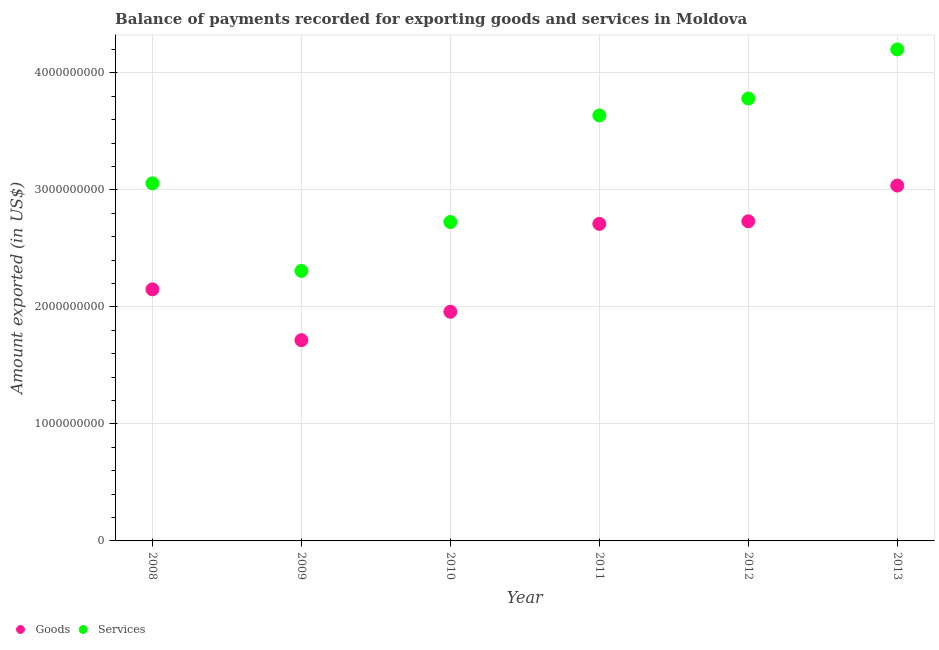Is the number of dotlines equal to the number of legend labels?
Provide a short and direct response. Yes. What is the amount of goods exported in 2013?
Make the answer very short. 3.04e+09. Across all years, what is the maximum amount of goods exported?
Your response must be concise. 3.04e+09. Across all years, what is the minimum amount of goods exported?
Offer a terse response. 1.72e+09. In which year was the amount of goods exported minimum?
Give a very brief answer. 2009. What is the total amount of goods exported in the graph?
Provide a succinct answer. 1.43e+1. What is the difference between the amount of services exported in 2010 and that in 2012?
Make the answer very short. -1.06e+09. What is the difference between the amount of goods exported in 2011 and the amount of services exported in 2012?
Your answer should be compact. -1.07e+09. What is the average amount of goods exported per year?
Ensure brevity in your answer.  2.38e+09. In the year 2012, what is the difference between the amount of services exported and amount of goods exported?
Your response must be concise. 1.05e+09. What is the ratio of the amount of goods exported in 2009 to that in 2012?
Provide a succinct answer. 0.63. What is the difference between the highest and the second highest amount of services exported?
Make the answer very short. 4.20e+08. What is the difference between the highest and the lowest amount of services exported?
Your response must be concise. 1.89e+09. In how many years, is the amount of services exported greater than the average amount of services exported taken over all years?
Keep it short and to the point. 3. Is the sum of the amount of goods exported in 2008 and 2009 greater than the maximum amount of services exported across all years?
Provide a short and direct response. No. Does the amount of goods exported monotonically increase over the years?
Offer a terse response. No. Is the amount of goods exported strictly less than the amount of services exported over the years?
Offer a very short reply. Yes. How many dotlines are there?
Offer a very short reply. 2. Are the values on the major ticks of Y-axis written in scientific E-notation?
Offer a very short reply. No. Does the graph contain any zero values?
Ensure brevity in your answer.  No. Where does the legend appear in the graph?
Keep it short and to the point. Bottom left. How many legend labels are there?
Keep it short and to the point. 2. What is the title of the graph?
Provide a short and direct response. Balance of payments recorded for exporting goods and services in Moldova. Does "Health Care" appear as one of the legend labels in the graph?
Provide a short and direct response. No. What is the label or title of the X-axis?
Keep it short and to the point. Year. What is the label or title of the Y-axis?
Provide a succinct answer. Amount exported (in US$). What is the Amount exported (in US$) of Goods in 2008?
Offer a very short reply. 2.15e+09. What is the Amount exported (in US$) in Services in 2008?
Your answer should be very brief. 3.06e+09. What is the Amount exported (in US$) in Goods in 2009?
Offer a very short reply. 1.72e+09. What is the Amount exported (in US$) of Services in 2009?
Provide a succinct answer. 2.31e+09. What is the Amount exported (in US$) of Goods in 2010?
Provide a succinct answer. 1.96e+09. What is the Amount exported (in US$) of Services in 2010?
Ensure brevity in your answer.  2.73e+09. What is the Amount exported (in US$) in Goods in 2011?
Provide a succinct answer. 2.71e+09. What is the Amount exported (in US$) in Services in 2011?
Your response must be concise. 3.64e+09. What is the Amount exported (in US$) in Goods in 2012?
Make the answer very short. 2.73e+09. What is the Amount exported (in US$) in Services in 2012?
Provide a succinct answer. 3.78e+09. What is the Amount exported (in US$) in Goods in 2013?
Provide a short and direct response. 3.04e+09. What is the Amount exported (in US$) in Services in 2013?
Keep it short and to the point. 4.20e+09. Across all years, what is the maximum Amount exported (in US$) in Goods?
Make the answer very short. 3.04e+09. Across all years, what is the maximum Amount exported (in US$) of Services?
Your answer should be very brief. 4.20e+09. Across all years, what is the minimum Amount exported (in US$) in Goods?
Ensure brevity in your answer.  1.72e+09. Across all years, what is the minimum Amount exported (in US$) in Services?
Give a very brief answer. 2.31e+09. What is the total Amount exported (in US$) in Goods in the graph?
Ensure brevity in your answer.  1.43e+1. What is the total Amount exported (in US$) in Services in the graph?
Provide a short and direct response. 1.97e+1. What is the difference between the Amount exported (in US$) in Goods in 2008 and that in 2009?
Ensure brevity in your answer.  4.34e+08. What is the difference between the Amount exported (in US$) of Services in 2008 and that in 2009?
Offer a very short reply. 7.48e+08. What is the difference between the Amount exported (in US$) of Goods in 2008 and that in 2010?
Offer a very short reply. 1.92e+08. What is the difference between the Amount exported (in US$) of Services in 2008 and that in 2010?
Make the answer very short. 3.31e+08. What is the difference between the Amount exported (in US$) of Goods in 2008 and that in 2011?
Ensure brevity in your answer.  -5.60e+08. What is the difference between the Amount exported (in US$) of Services in 2008 and that in 2011?
Make the answer very short. -5.80e+08. What is the difference between the Amount exported (in US$) of Goods in 2008 and that in 2012?
Your answer should be very brief. -5.82e+08. What is the difference between the Amount exported (in US$) of Services in 2008 and that in 2012?
Your answer should be very brief. -7.25e+08. What is the difference between the Amount exported (in US$) in Goods in 2008 and that in 2013?
Give a very brief answer. -8.87e+08. What is the difference between the Amount exported (in US$) in Services in 2008 and that in 2013?
Ensure brevity in your answer.  -1.14e+09. What is the difference between the Amount exported (in US$) of Goods in 2009 and that in 2010?
Offer a terse response. -2.43e+08. What is the difference between the Amount exported (in US$) of Services in 2009 and that in 2010?
Ensure brevity in your answer.  -4.18e+08. What is the difference between the Amount exported (in US$) in Goods in 2009 and that in 2011?
Provide a succinct answer. -9.94e+08. What is the difference between the Amount exported (in US$) in Services in 2009 and that in 2011?
Provide a short and direct response. -1.33e+09. What is the difference between the Amount exported (in US$) in Goods in 2009 and that in 2012?
Your response must be concise. -1.02e+09. What is the difference between the Amount exported (in US$) in Services in 2009 and that in 2012?
Your answer should be very brief. -1.47e+09. What is the difference between the Amount exported (in US$) in Goods in 2009 and that in 2013?
Your answer should be very brief. -1.32e+09. What is the difference between the Amount exported (in US$) in Services in 2009 and that in 2013?
Offer a very short reply. -1.89e+09. What is the difference between the Amount exported (in US$) of Goods in 2010 and that in 2011?
Make the answer very short. -7.51e+08. What is the difference between the Amount exported (in US$) of Services in 2010 and that in 2011?
Provide a short and direct response. -9.11e+08. What is the difference between the Amount exported (in US$) of Goods in 2010 and that in 2012?
Provide a short and direct response. -7.73e+08. What is the difference between the Amount exported (in US$) in Services in 2010 and that in 2012?
Keep it short and to the point. -1.06e+09. What is the difference between the Amount exported (in US$) in Goods in 2010 and that in 2013?
Offer a terse response. -1.08e+09. What is the difference between the Amount exported (in US$) in Services in 2010 and that in 2013?
Keep it short and to the point. -1.48e+09. What is the difference between the Amount exported (in US$) in Goods in 2011 and that in 2012?
Ensure brevity in your answer.  -2.19e+07. What is the difference between the Amount exported (in US$) of Services in 2011 and that in 2012?
Your answer should be very brief. -1.45e+08. What is the difference between the Amount exported (in US$) in Goods in 2011 and that in 2013?
Your answer should be very brief. -3.28e+08. What is the difference between the Amount exported (in US$) in Services in 2011 and that in 2013?
Make the answer very short. -5.64e+08. What is the difference between the Amount exported (in US$) of Goods in 2012 and that in 2013?
Your answer should be very brief. -3.06e+08. What is the difference between the Amount exported (in US$) in Services in 2012 and that in 2013?
Provide a succinct answer. -4.20e+08. What is the difference between the Amount exported (in US$) of Goods in 2008 and the Amount exported (in US$) of Services in 2009?
Ensure brevity in your answer.  -1.58e+08. What is the difference between the Amount exported (in US$) in Goods in 2008 and the Amount exported (in US$) in Services in 2010?
Your response must be concise. -5.75e+08. What is the difference between the Amount exported (in US$) in Goods in 2008 and the Amount exported (in US$) in Services in 2011?
Your answer should be compact. -1.49e+09. What is the difference between the Amount exported (in US$) in Goods in 2008 and the Amount exported (in US$) in Services in 2012?
Your answer should be very brief. -1.63e+09. What is the difference between the Amount exported (in US$) of Goods in 2008 and the Amount exported (in US$) of Services in 2013?
Your answer should be very brief. -2.05e+09. What is the difference between the Amount exported (in US$) in Goods in 2009 and the Amount exported (in US$) in Services in 2010?
Offer a terse response. -1.01e+09. What is the difference between the Amount exported (in US$) of Goods in 2009 and the Amount exported (in US$) of Services in 2011?
Ensure brevity in your answer.  -1.92e+09. What is the difference between the Amount exported (in US$) in Goods in 2009 and the Amount exported (in US$) in Services in 2012?
Your response must be concise. -2.07e+09. What is the difference between the Amount exported (in US$) of Goods in 2009 and the Amount exported (in US$) of Services in 2013?
Your answer should be compact. -2.48e+09. What is the difference between the Amount exported (in US$) in Goods in 2010 and the Amount exported (in US$) in Services in 2011?
Give a very brief answer. -1.68e+09. What is the difference between the Amount exported (in US$) in Goods in 2010 and the Amount exported (in US$) in Services in 2012?
Ensure brevity in your answer.  -1.82e+09. What is the difference between the Amount exported (in US$) in Goods in 2010 and the Amount exported (in US$) in Services in 2013?
Provide a succinct answer. -2.24e+09. What is the difference between the Amount exported (in US$) in Goods in 2011 and the Amount exported (in US$) in Services in 2012?
Your response must be concise. -1.07e+09. What is the difference between the Amount exported (in US$) in Goods in 2011 and the Amount exported (in US$) in Services in 2013?
Your answer should be very brief. -1.49e+09. What is the difference between the Amount exported (in US$) in Goods in 2012 and the Amount exported (in US$) in Services in 2013?
Provide a short and direct response. -1.47e+09. What is the average Amount exported (in US$) of Goods per year?
Offer a very short reply. 2.38e+09. What is the average Amount exported (in US$) of Services per year?
Your response must be concise. 3.28e+09. In the year 2008, what is the difference between the Amount exported (in US$) in Goods and Amount exported (in US$) in Services?
Give a very brief answer. -9.06e+08. In the year 2009, what is the difference between the Amount exported (in US$) in Goods and Amount exported (in US$) in Services?
Provide a succinct answer. -5.92e+08. In the year 2010, what is the difference between the Amount exported (in US$) of Goods and Amount exported (in US$) of Services?
Make the answer very short. -7.67e+08. In the year 2011, what is the difference between the Amount exported (in US$) of Goods and Amount exported (in US$) of Services?
Give a very brief answer. -9.27e+08. In the year 2012, what is the difference between the Amount exported (in US$) of Goods and Amount exported (in US$) of Services?
Your answer should be very brief. -1.05e+09. In the year 2013, what is the difference between the Amount exported (in US$) of Goods and Amount exported (in US$) of Services?
Your response must be concise. -1.16e+09. What is the ratio of the Amount exported (in US$) of Goods in 2008 to that in 2009?
Offer a terse response. 1.25. What is the ratio of the Amount exported (in US$) of Services in 2008 to that in 2009?
Your answer should be very brief. 1.32. What is the ratio of the Amount exported (in US$) in Goods in 2008 to that in 2010?
Make the answer very short. 1.1. What is the ratio of the Amount exported (in US$) in Services in 2008 to that in 2010?
Provide a succinct answer. 1.12. What is the ratio of the Amount exported (in US$) of Goods in 2008 to that in 2011?
Provide a short and direct response. 0.79. What is the ratio of the Amount exported (in US$) in Services in 2008 to that in 2011?
Offer a very short reply. 0.84. What is the ratio of the Amount exported (in US$) of Goods in 2008 to that in 2012?
Keep it short and to the point. 0.79. What is the ratio of the Amount exported (in US$) of Services in 2008 to that in 2012?
Your answer should be compact. 0.81. What is the ratio of the Amount exported (in US$) in Goods in 2008 to that in 2013?
Your answer should be very brief. 0.71. What is the ratio of the Amount exported (in US$) in Services in 2008 to that in 2013?
Ensure brevity in your answer.  0.73. What is the ratio of the Amount exported (in US$) in Goods in 2009 to that in 2010?
Give a very brief answer. 0.88. What is the ratio of the Amount exported (in US$) of Services in 2009 to that in 2010?
Give a very brief answer. 0.85. What is the ratio of the Amount exported (in US$) of Goods in 2009 to that in 2011?
Make the answer very short. 0.63. What is the ratio of the Amount exported (in US$) of Services in 2009 to that in 2011?
Make the answer very short. 0.63. What is the ratio of the Amount exported (in US$) in Goods in 2009 to that in 2012?
Your answer should be very brief. 0.63. What is the ratio of the Amount exported (in US$) of Services in 2009 to that in 2012?
Your response must be concise. 0.61. What is the ratio of the Amount exported (in US$) of Goods in 2009 to that in 2013?
Offer a terse response. 0.56. What is the ratio of the Amount exported (in US$) in Services in 2009 to that in 2013?
Make the answer very short. 0.55. What is the ratio of the Amount exported (in US$) in Goods in 2010 to that in 2011?
Ensure brevity in your answer.  0.72. What is the ratio of the Amount exported (in US$) of Services in 2010 to that in 2011?
Provide a short and direct response. 0.75. What is the ratio of the Amount exported (in US$) in Goods in 2010 to that in 2012?
Keep it short and to the point. 0.72. What is the ratio of the Amount exported (in US$) in Services in 2010 to that in 2012?
Keep it short and to the point. 0.72. What is the ratio of the Amount exported (in US$) of Goods in 2010 to that in 2013?
Your answer should be very brief. 0.64. What is the ratio of the Amount exported (in US$) of Services in 2010 to that in 2013?
Make the answer very short. 0.65. What is the ratio of the Amount exported (in US$) of Services in 2011 to that in 2012?
Give a very brief answer. 0.96. What is the ratio of the Amount exported (in US$) in Goods in 2011 to that in 2013?
Provide a succinct answer. 0.89. What is the ratio of the Amount exported (in US$) of Services in 2011 to that in 2013?
Make the answer very short. 0.87. What is the ratio of the Amount exported (in US$) in Goods in 2012 to that in 2013?
Offer a terse response. 0.9. What is the ratio of the Amount exported (in US$) in Services in 2012 to that in 2013?
Your response must be concise. 0.9. What is the difference between the highest and the second highest Amount exported (in US$) of Goods?
Your answer should be very brief. 3.06e+08. What is the difference between the highest and the second highest Amount exported (in US$) of Services?
Provide a succinct answer. 4.20e+08. What is the difference between the highest and the lowest Amount exported (in US$) in Goods?
Give a very brief answer. 1.32e+09. What is the difference between the highest and the lowest Amount exported (in US$) in Services?
Give a very brief answer. 1.89e+09. 